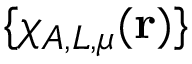<formula> <loc_0><loc_0><loc_500><loc_500>\{ \chi _ { A , L , \mu } ( r ) \}</formula> 